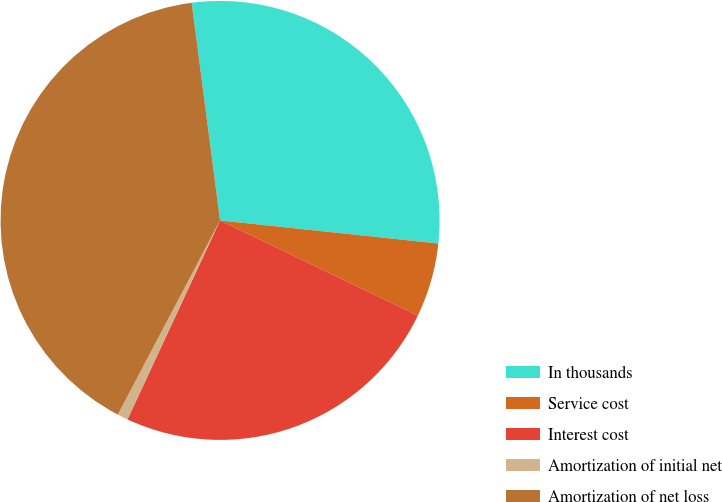Convert chart. <chart><loc_0><loc_0><loc_500><loc_500><pie_chart><fcel>In thousands<fcel>Service cost<fcel>Interest cost<fcel>Amortization of initial net<fcel>Amortization of net loss<nl><fcel>28.74%<fcel>5.46%<fcel>24.79%<fcel>0.78%<fcel>40.22%<nl></chart> 